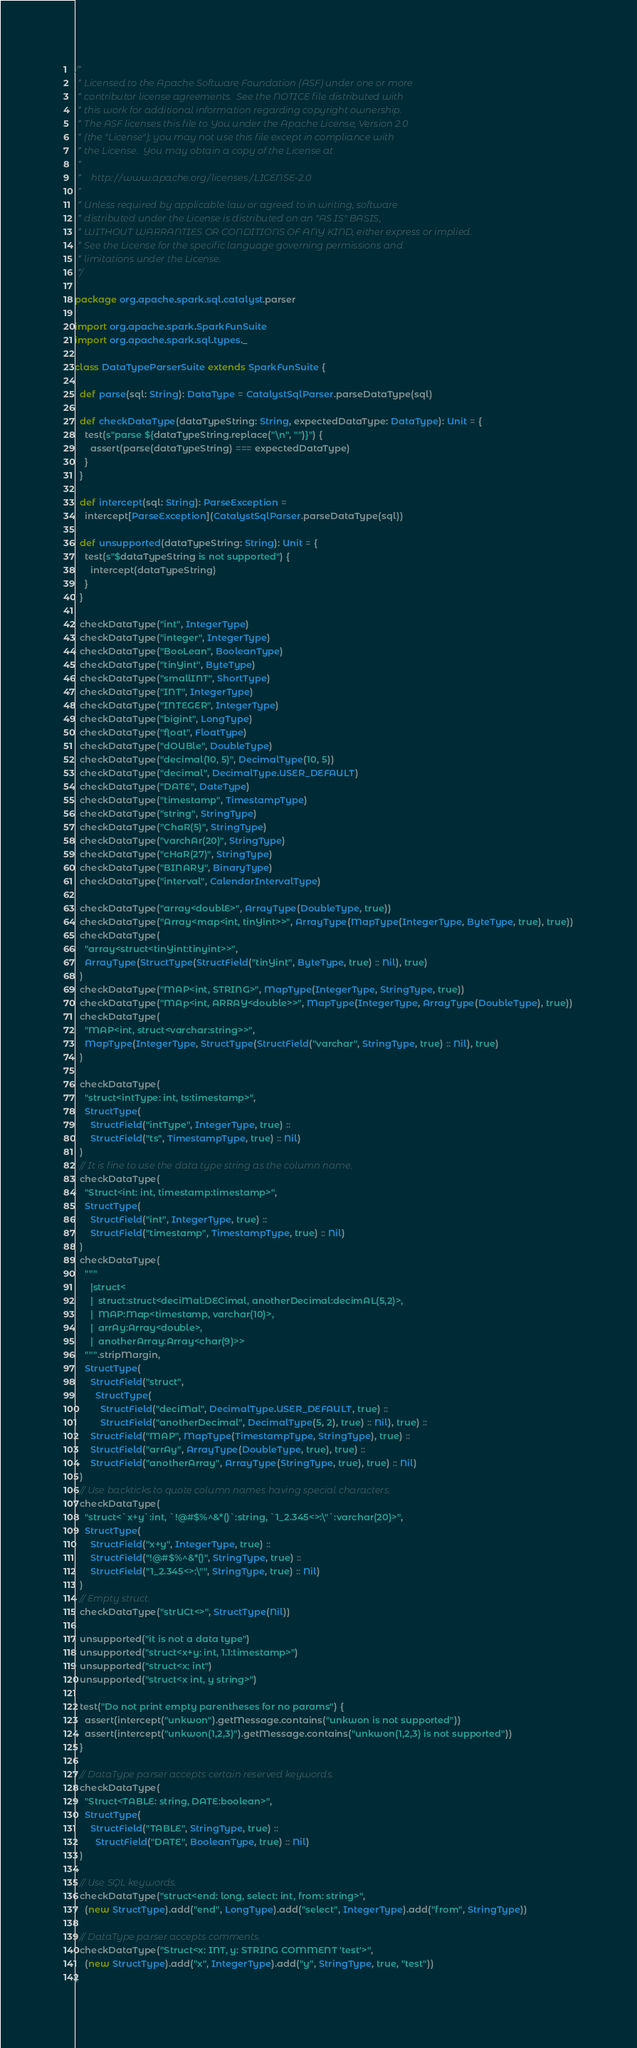Convert code to text. <code><loc_0><loc_0><loc_500><loc_500><_Scala_>/*
 * Licensed to the Apache Software Foundation (ASF) under one or more
 * contributor license agreements.  See the NOTICE file distributed with
 * this work for additional information regarding copyright ownership.
 * The ASF licenses this file to You under the Apache License, Version 2.0
 * (the "License"); you may not use this file except in compliance with
 * the License.  You may obtain a copy of the License at
 *
 *    http://www.apache.org/licenses/LICENSE-2.0
 *
 * Unless required by applicable law or agreed to in writing, software
 * distributed under the License is distributed on an "AS IS" BASIS,
 * WITHOUT WARRANTIES OR CONDITIONS OF ANY KIND, either express or implied.
 * See the License for the specific language governing permissions and
 * limitations under the License.
 */

package org.apache.spark.sql.catalyst.parser

import org.apache.spark.SparkFunSuite
import org.apache.spark.sql.types._

class DataTypeParserSuite extends SparkFunSuite {

  def parse(sql: String): DataType = CatalystSqlParser.parseDataType(sql)

  def checkDataType(dataTypeString: String, expectedDataType: DataType): Unit = {
    test(s"parse ${dataTypeString.replace("\n", "")}") {
      assert(parse(dataTypeString) === expectedDataType)
    }
  }

  def intercept(sql: String): ParseException =
    intercept[ParseException](CatalystSqlParser.parseDataType(sql))

  def unsupported(dataTypeString: String): Unit = {
    test(s"$dataTypeString is not supported") {
      intercept(dataTypeString)
    }
  }

  checkDataType("int", IntegerType)
  checkDataType("integer", IntegerType)
  checkDataType("BooLean", BooleanType)
  checkDataType("tinYint", ByteType)
  checkDataType("smallINT", ShortType)
  checkDataType("INT", IntegerType)
  checkDataType("INTEGER", IntegerType)
  checkDataType("bigint", LongType)
  checkDataType("float", FloatType)
  checkDataType("dOUBle", DoubleType)
  checkDataType("decimal(10, 5)", DecimalType(10, 5))
  checkDataType("decimal", DecimalType.USER_DEFAULT)
  checkDataType("DATE", DateType)
  checkDataType("timestamp", TimestampType)
  checkDataType("string", StringType)
  checkDataType("ChaR(5)", StringType)
  checkDataType("varchAr(20)", StringType)
  checkDataType("cHaR(27)", StringType)
  checkDataType("BINARY", BinaryType)
  checkDataType("interval", CalendarIntervalType)

  checkDataType("array<doublE>", ArrayType(DoubleType, true))
  checkDataType("Array<map<int, tinYint>>", ArrayType(MapType(IntegerType, ByteType, true), true))
  checkDataType(
    "array<struct<tinYint:tinyint>>",
    ArrayType(StructType(StructField("tinYint", ByteType, true) :: Nil), true)
  )
  checkDataType("MAP<int, STRING>", MapType(IntegerType, StringType, true))
  checkDataType("MAp<int, ARRAY<double>>", MapType(IntegerType, ArrayType(DoubleType), true))
  checkDataType(
    "MAP<int, struct<varchar:string>>",
    MapType(IntegerType, StructType(StructField("varchar", StringType, true) :: Nil), true)
  )

  checkDataType(
    "struct<intType: int, ts:timestamp>",
    StructType(
      StructField("intType", IntegerType, true) ::
      StructField("ts", TimestampType, true) :: Nil)
  )
  // It is fine to use the data type string as the column name.
  checkDataType(
    "Struct<int: int, timestamp:timestamp>",
    StructType(
      StructField("int", IntegerType, true) ::
      StructField("timestamp", TimestampType, true) :: Nil)
  )
  checkDataType(
    """
      |struct<
      |  struct:struct<deciMal:DECimal, anotherDecimal:decimAL(5,2)>,
      |  MAP:Map<timestamp, varchar(10)>,
      |  arrAy:Array<double>,
      |  anotherArray:Array<char(9)>>
    """.stripMargin,
    StructType(
      StructField("struct",
        StructType(
          StructField("deciMal", DecimalType.USER_DEFAULT, true) ::
          StructField("anotherDecimal", DecimalType(5, 2), true) :: Nil), true) ::
      StructField("MAP", MapType(TimestampType, StringType), true) ::
      StructField("arrAy", ArrayType(DoubleType, true), true) ::
      StructField("anotherArray", ArrayType(StringType, true), true) :: Nil)
  )
  // Use backticks to quote column names having special characters.
  checkDataType(
    "struct<`x+y`:int, `!@#$%^&*()`:string, `1_2.345<>:\"`:varchar(20)>",
    StructType(
      StructField("x+y", IntegerType, true) ::
      StructField("!@#$%^&*()", StringType, true) ::
      StructField("1_2.345<>:\"", StringType, true) :: Nil)
  )
  // Empty struct.
  checkDataType("strUCt<>", StructType(Nil))

  unsupported("it is not a data type")
  unsupported("struct<x+y: int, 1.1:timestamp>")
  unsupported("struct<x: int")
  unsupported("struct<x int, y string>")

  test("Do not print empty parentheses for no params") {
    assert(intercept("unkwon").getMessage.contains("unkwon is not supported"))
    assert(intercept("unkwon(1,2,3)").getMessage.contains("unkwon(1,2,3) is not supported"))
  }

  // DataType parser accepts certain reserved keywords.
  checkDataType(
    "Struct<TABLE: string, DATE:boolean>",
    StructType(
      StructField("TABLE", StringType, true) ::
        StructField("DATE", BooleanType, true) :: Nil)
  )

  // Use SQL keywords.
  checkDataType("struct<end: long, select: int, from: string>",
    (new StructType).add("end", LongType).add("select", IntegerType).add("from", StringType))

  // DataType parser accepts comments.
  checkDataType("Struct<x: INT, y: STRING COMMENT 'test'>",
    (new StructType).add("x", IntegerType).add("y", StringType, true, "test"))
}
</code> 